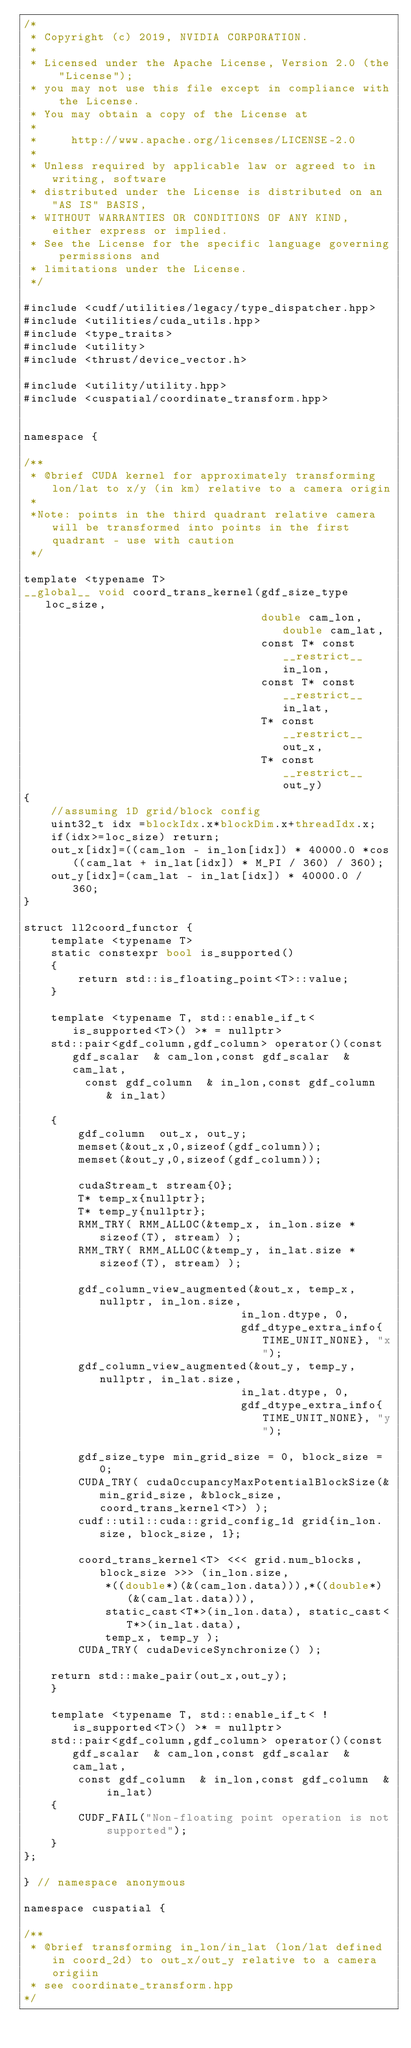Convert code to text. <code><loc_0><loc_0><loc_500><loc_500><_Cuda_>/*
 * Copyright (c) 2019, NVIDIA CORPORATION.
 *
 * Licensed under the Apache License, Version 2.0 (the "License");
 * you may not use this file except in compliance with the License.
 * You may obtain a copy of the License at
 *
 *     http://www.apache.org/licenses/LICENSE-2.0
 *
 * Unless required by applicable law or agreed to in writing, software
 * distributed under the License is distributed on an "AS IS" BASIS,
 * WITHOUT WARRANTIES OR CONDITIONS OF ANY KIND, either express or implied.
 * See the License for the specific language governing permissions and
 * limitations under the License.
 */

#include <cudf/utilities/legacy/type_dispatcher.hpp>
#include <utilities/cuda_utils.hpp>
#include <type_traits>
#include <utility>
#include <thrust/device_vector.h>

#include <utility/utility.hpp>
#include <cuspatial/coordinate_transform.hpp>


namespace {

/**
 * @brief CUDA kernel for approximately transforming lon/lat to x/y (in km) relative to a camera origin
 *
 *Note: points in the third quadrant relative camera will be transformed into points in the first quadrant - use with caution
 */

template <typename T>
__global__ void coord_trans_kernel(gdf_size_type loc_size,
                                   double cam_lon, double cam_lat,
                                   const T* const __restrict__ in_lon,
                                   const T* const __restrict__ in_lat,
                                   T* const __restrict__ out_x,
                                   T* const __restrict__ out_y)
{
    //assuming 1D grid/block config
    uint32_t idx =blockIdx.x*blockDim.x+threadIdx.x;
    if(idx>=loc_size) return;    
    out_x[idx]=((cam_lon - in_lon[idx]) * 40000.0 *cos((cam_lat + in_lat[idx]) * M_PI / 360) / 360);
    out_y[idx]=(cam_lat - in_lat[idx]) * 40000.0 / 360;
}

struct ll2coord_functor {
    template <typename T>
    static constexpr bool is_supported()
    {
        return std::is_floating_point<T>::value;
    }

    template <typename T, std::enable_if_t< is_supported<T>() >* = nullptr>
    std::pair<gdf_column,gdf_column> operator()(const gdf_scalar  & cam_lon,const gdf_scalar  & cam_lat,
    	 const gdf_column  & in_lon,const gdf_column  & in_lat)
    	
    {
        gdf_column  out_x, out_y;
        memset(&out_x,0,sizeof(gdf_column));
        memset(&out_y,0,sizeof(gdf_column));
        
        cudaStream_t stream{0};
        T* temp_x{nullptr};
        T* temp_y{nullptr};
        RMM_TRY( RMM_ALLOC(&temp_x, in_lon.size * sizeof(T), stream) );
        RMM_TRY( RMM_ALLOC(&temp_y, in_lat.size * sizeof(T), stream) );

        gdf_column_view_augmented(&out_x, temp_x, nullptr, in_lon.size,
                                in_lon.dtype, 0,
                                gdf_dtype_extra_info{TIME_UNIT_NONE}, "x");          
        gdf_column_view_augmented(&out_y, temp_y, nullptr, in_lat.size,
                                in_lat.dtype, 0,
                                gdf_dtype_extra_info{TIME_UNIT_NONE}, "y");          

        gdf_size_type min_grid_size = 0, block_size = 0;
        CUDA_TRY( cudaOccupancyMaxPotentialBlockSize(&min_grid_size, &block_size, coord_trans_kernel<T>) );
        cudf::util::cuda::grid_config_1d grid{in_lon.size, block_size, 1};
       
        coord_trans_kernel<T> <<< grid.num_blocks, block_size >>> (in_lon.size,
        	*((double*)(&(cam_lon.data))),*((double*)(&(cam_lat.data))),
   	    	static_cast<T*>(in_lon.data), static_cast<T*>(in_lat.data),
   	    	temp_x, temp_y );           
        CUDA_TRY( cudaDeviceSynchronize() );
	
 	return std::make_pair(out_x,out_y);
    }

    template <typename T, std::enable_if_t< !is_supported<T>() >* = nullptr>
    std::pair<gdf_column,gdf_column> operator()(const gdf_scalar  & cam_lon,const gdf_scalar  & cam_lat,
    	const gdf_column  & in_lon,const gdf_column  & in_lat)
    {
        CUDF_FAIL("Non-floating point operation is not supported");
    }
};

} // namespace anonymous        

namespace cuspatial {

/**
 * @brief transforming in_lon/in_lat (lon/lat defined in coord_2d) to out_x/out_y relative to a camera origiin
 * see coordinate_transform.hpp
*/
</code> 